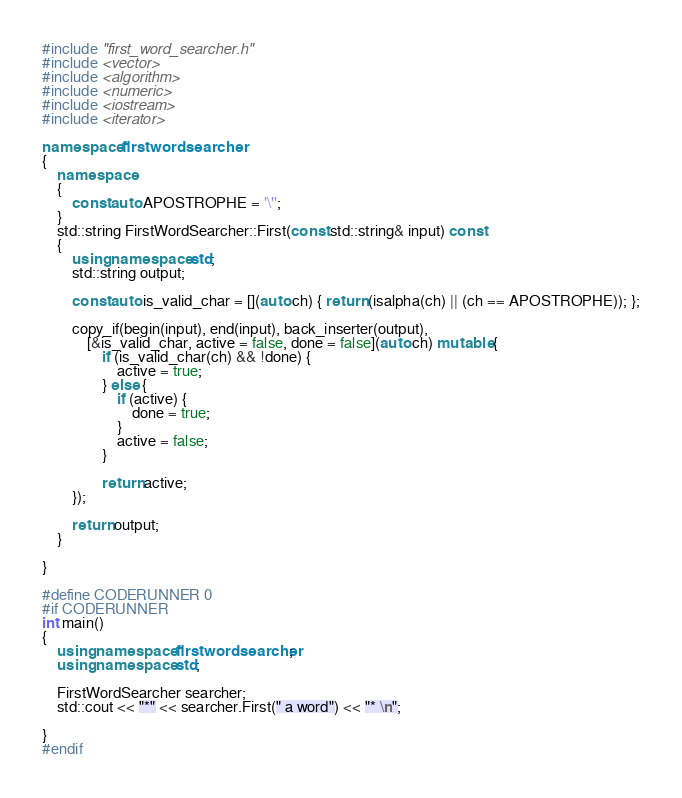Convert code to text. <code><loc_0><loc_0><loc_500><loc_500><_C++_>#include "first_word_searcher.h"
#include <vector>
#include <algorithm>
#include <numeric>
#include <iostream>
#include <iterator>

namespace firstwordsearcher
{
    namespace
    {
        const auto APOSTROPHE = '\'';
    }
    std::string FirstWordSearcher::First(const std::string& input) const
    {
        using namespace std;
        std::string output;

        const auto is_valid_char = [](auto ch) { return (isalpha(ch) || (ch == APOSTROPHE)); };

        copy_if(begin(input), end(input), back_inserter(output),
            [&is_valid_char, active = false, done = false](auto ch) mutable {
                if (is_valid_char(ch) && !done) {
                    active = true;
                } else {
                    if (active) {
                        done = true;
                    }
                    active = false;
                }

                return active;
        });

        return output;
    }

}

#define CODERUNNER 0
#if CODERUNNER
int main()
{
    using namespace firstwordsearcher;
    using namespace std;

    FirstWordSearcher searcher;
    std::cout << "*" << searcher.First(" a word") << "* \n";

}
#endif
</code> 